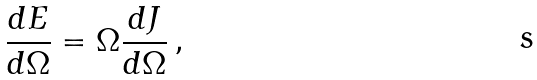Convert formula to latex. <formula><loc_0><loc_0><loc_500><loc_500>\frac { d E } { d \Omega } = \Omega \frac { d J } { d \Omega } \, ,</formula> 